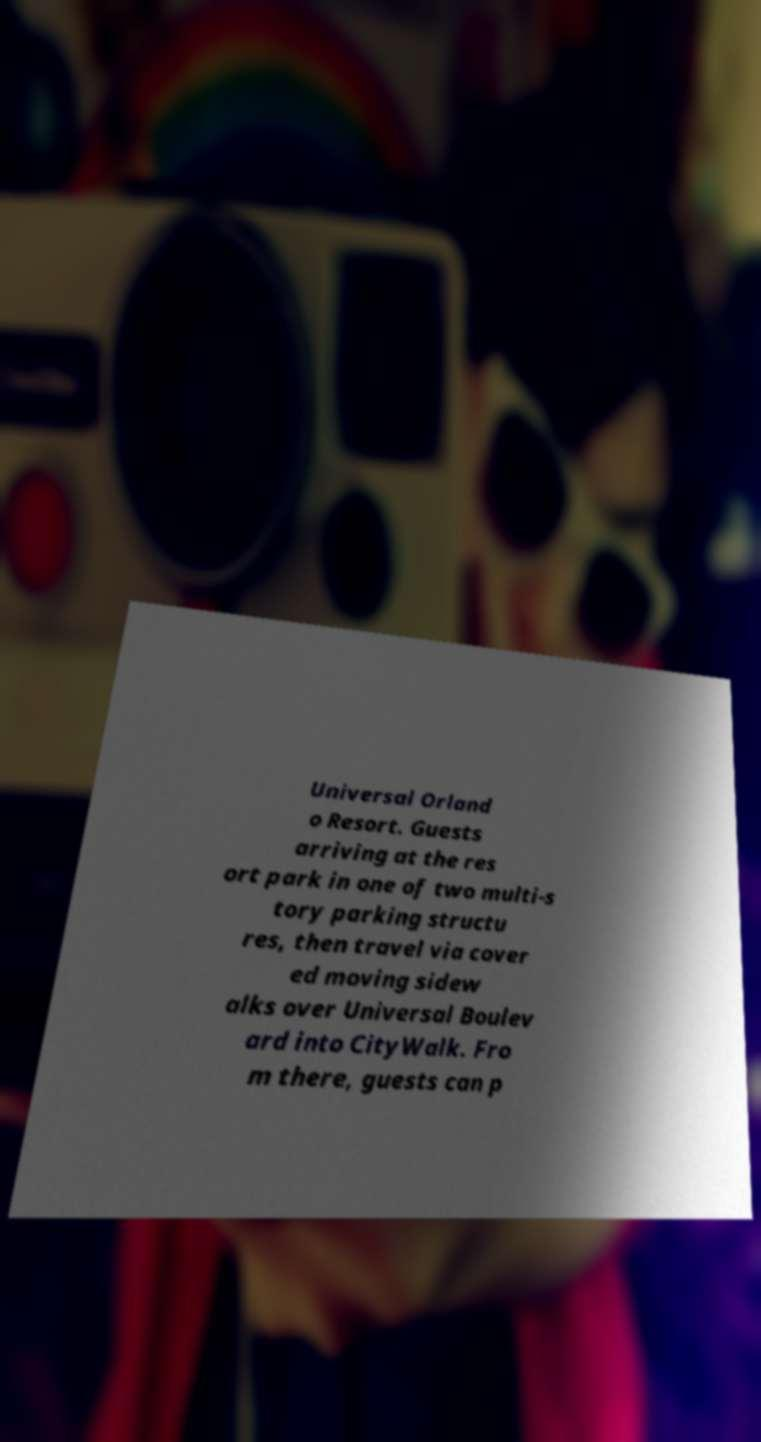Could you extract and type out the text from this image? Universal Orland o Resort. Guests arriving at the res ort park in one of two multi-s tory parking structu res, then travel via cover ed moving sidew alks over Universal Boulev ard into CityWalk. Fro m there, guests can p 